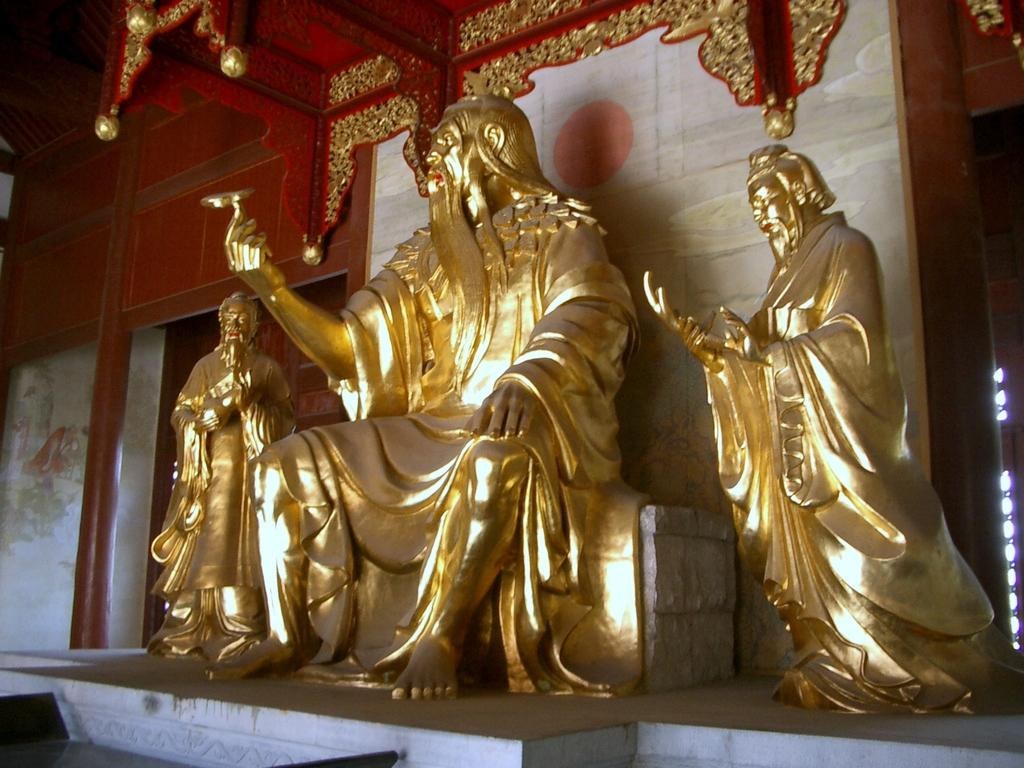How many idols are present in the image? There are three idols of a person in the image. Where are the idols located? The idols are on a wall. What can be seen in the background of the image? There is a red color pole in the background of the image. What type of boot is being used to apply toothpaste to the idols in the image? There is no boot or toothpaste present in the image; it only features three idols on a wall and a red color pole in the background. 